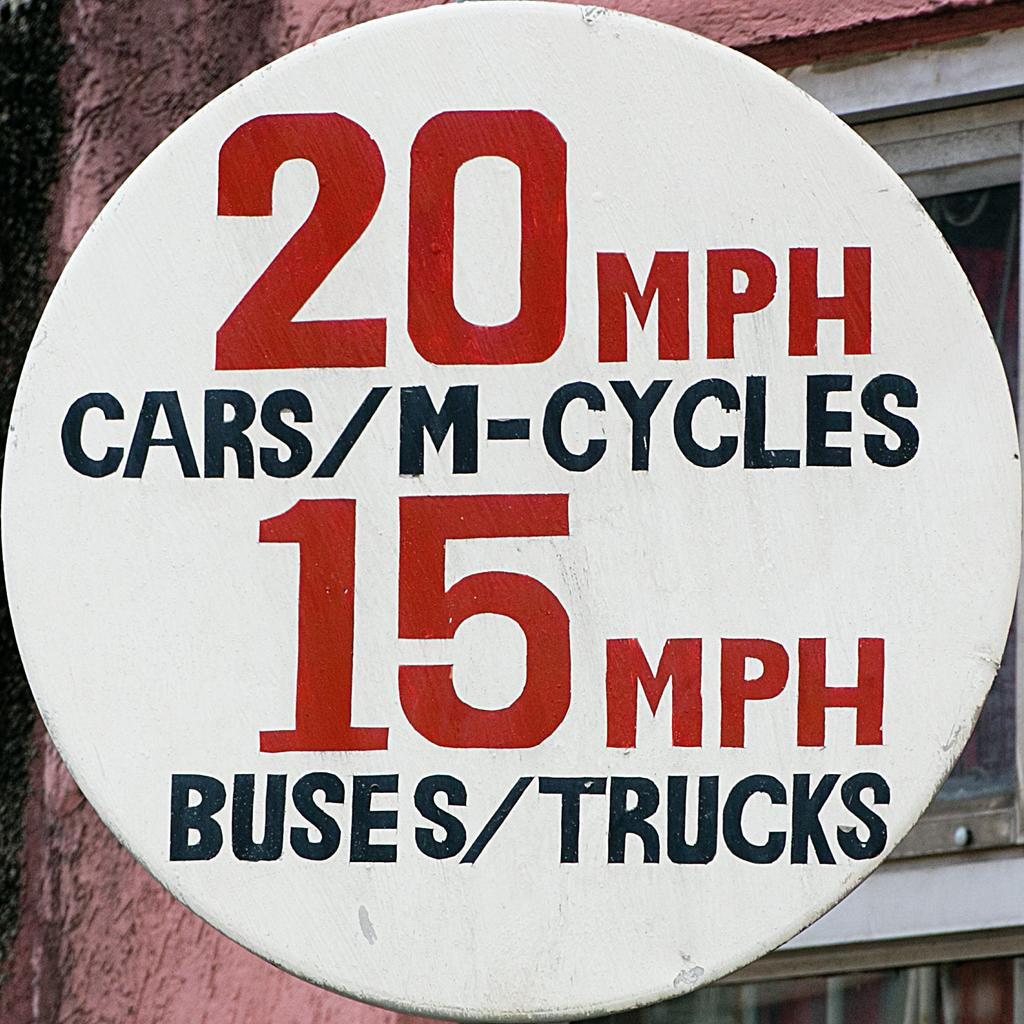<image>
Share a concise interpretation of the image provided. White sign with the red number 15 on it. 